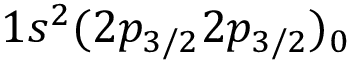Convert formula to latex. <formula><loc_0><loc_0><loc_500><loc_500>1 s ^ { 2 } ( 2 p _ { 3 / 2 } 2 p _ { 3 / 2 } ) _ { 0 }</formula> 